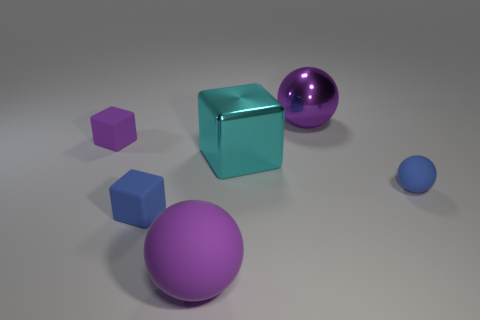Add 3 large cyan objects. How many objects exist? 9 Subtract 0 green cylinders. How many objects are left? 6 Subtract all tiny green matte objects. Subtract all large cyan metallic blocks. How many objects are left? 5 Add 6 large cyan metal objects. How many large cyan metal objects are left? 7 Add 5 big green metallic objects. How many big green metallic objects exist? 5 